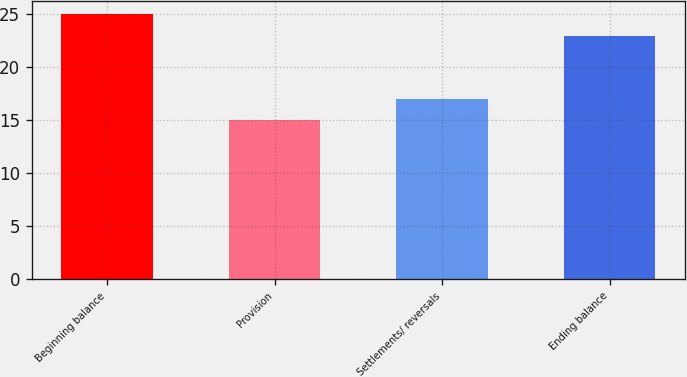Convert chart to OTSL. <chart><loc_0><loc_0><loc_500><loc_500><bar_chart><fcel>Beginning balance<fcel>Provision<fcel>Settlements/ reversals<fcel>Ending balance<nl><fcel>25<fcel>15<fcel>17<fcel>23<nl></chart> 